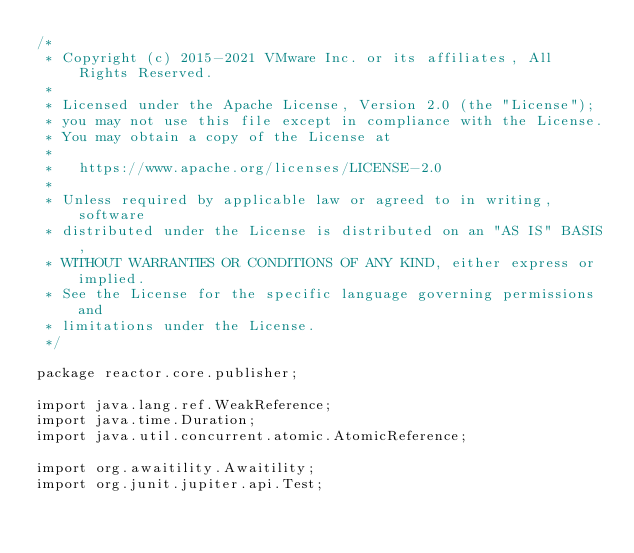Convert code to text. <code><loc_0><loc_0><loc_500><loc_500><_Java_>/*
 * Copyright (c) 2015-2021 VMware Inc. or its affiliates, All Rights Reserved.
 *
 * Licensed under the Apache License, Version 2.0 (the "License");
 * you may not use this file except in compliance with the License.
 * You may obtain a copy of the License at
 *
 *   https://www.apache.org/licenses/LICENSE-2.0
 *
 * Unless required by applicable law or agreed to in writing, software
 * distributed under the License is distributed on an "AS IS" BASIS,
 * WITHOUT WARRANTIES OR CONDITIONS OF ANY KIND, either express or implied.
 * See the License for the specific language governing permissions and
 * limitations under the License.
 */

package reactor.core.publisher;

import java.lang.ref.WeakReference;
import java.time.Duration;
import java.util.concurrent.atomic.AtomicReference;

import org.awaitility.Awaitility;
import org.junit.jupiter.api.Test;</code> 